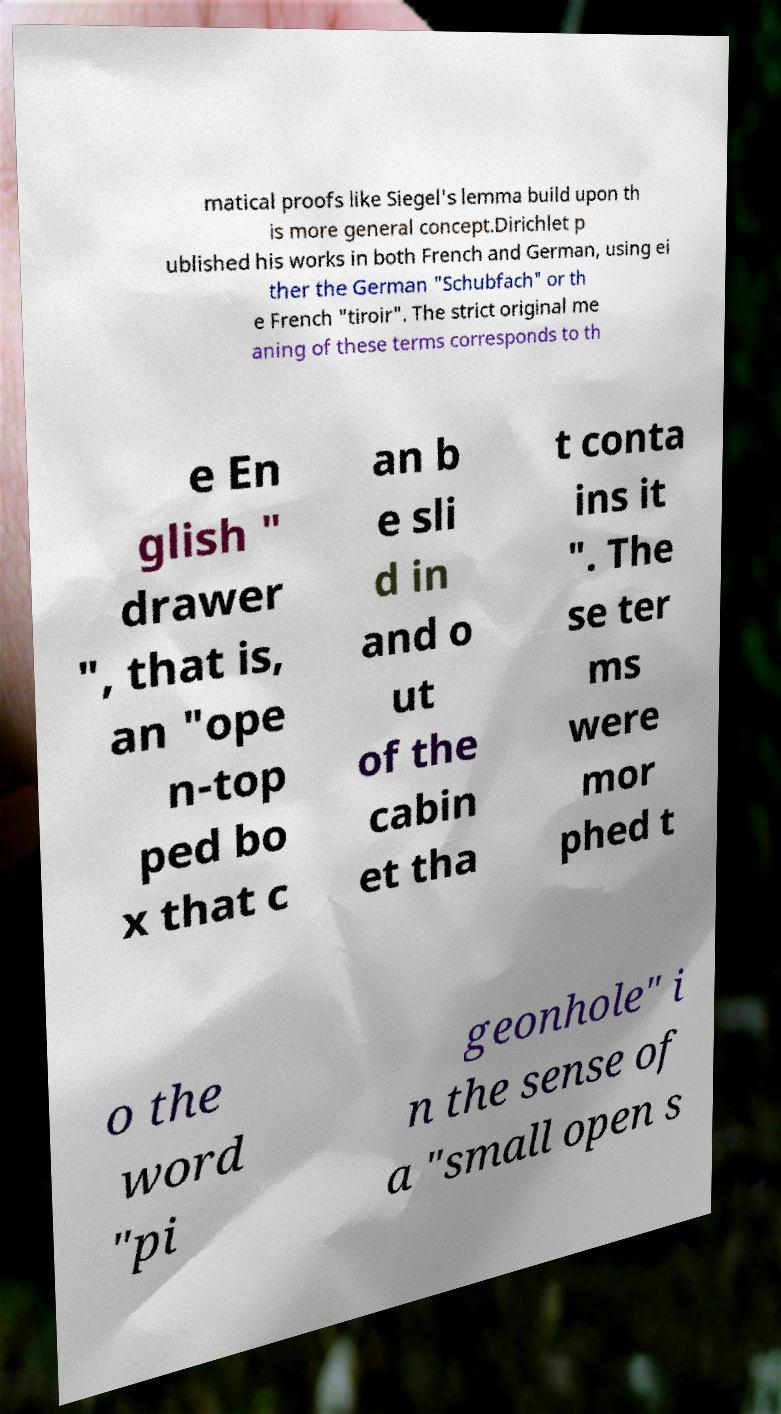Please read and relay the text visible in this image. What does it say? matical proofs like Siegel's lemma build upon th is more general concept.Dirichlet p ublished his works in both French and German, using ei ther the German "Schubfach" or th e French "tiroir". The strict original me aning of these terms corresponds to th e En glish " drawer ", that is, an "ope n-top ped bo x that c an b e sli d in and o ut of the cabin et tha t conta ins it ". The se ter ms were mor phed t o the word "pi geonhole" i n the sense of a "small open s 